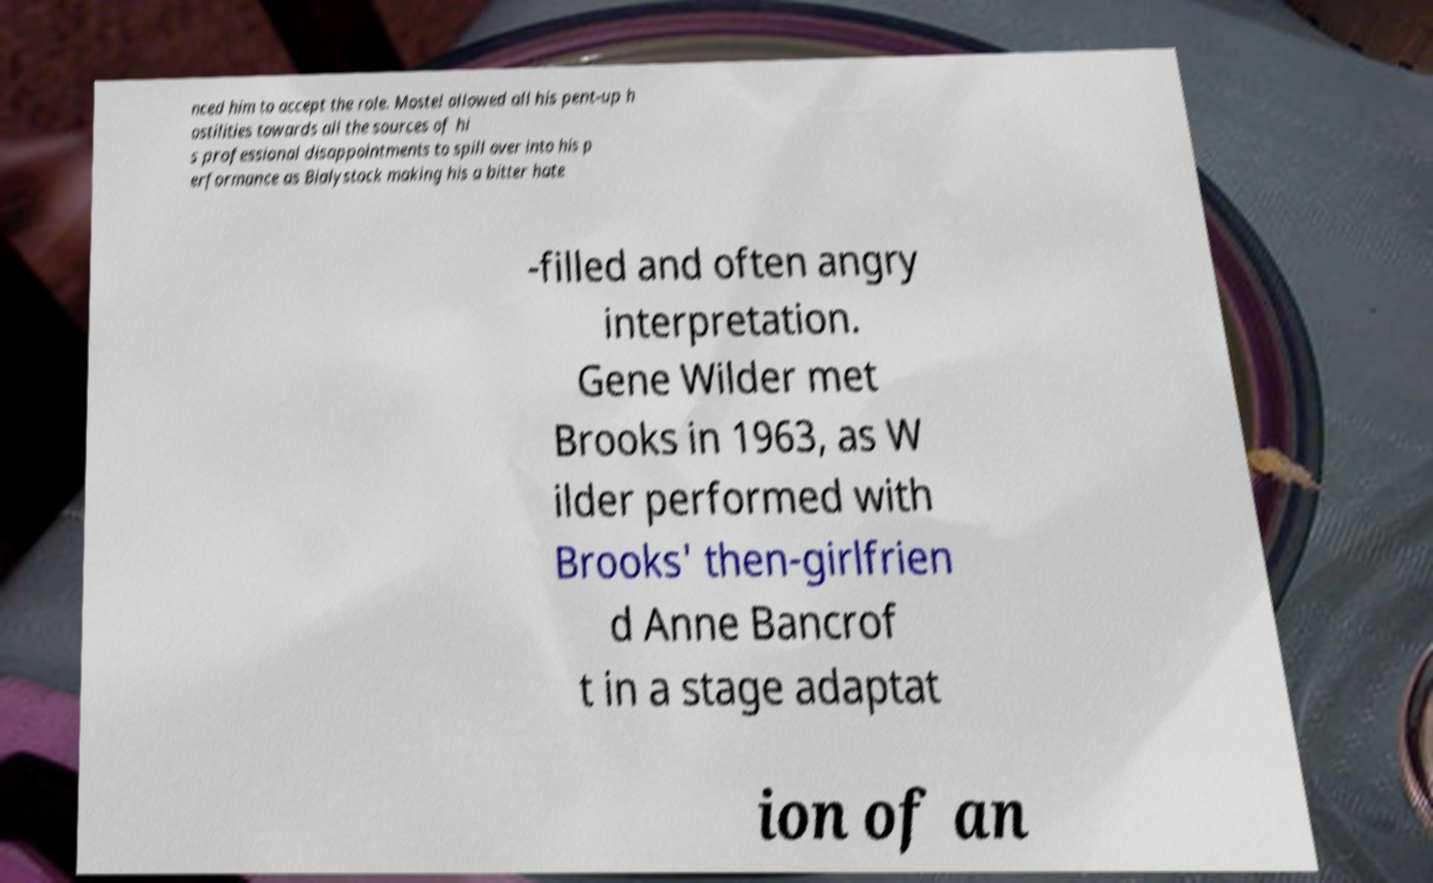For documentation purposes, I need the text within this image transcribed. Could you provide that? nced him to accept the role. Mostel allowed all his pent-up h ostilities towards all the sources of hi s professional disappointments to spill over into his p erformance as Bialystock making his a bitter hate -filled and often angry interpretation. Gene Wilder met Brooks in 1963, as W ilder performed with Brooks' then-girlfrien d Anne Bancrof t in a stage adaptat ion of an 